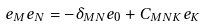Convert formula to latex. <formula><loc_0><loc_0><loc_500><loc_500>e _ { M } e _ { N } = - \delta _ { M N } e _ { 0 } + C _ { M N K } e _ { K }</formula> 